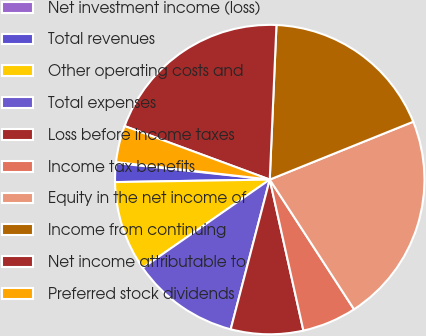<chart> <loc_0><loc_0><loc_500><loc_500><pie_chart><fcel>Net investment income (loss)<fcel>Total revenues<fcel>Other operating costs and<fcel>Total expenses<fcel>Loss before income taxes<fcel>Income tax benefits<fcel>Equity in the net income of<fcel>Income from continuing<fcel>Net income attributable to<fcel>Preferred stock dividends<nl><fcel>0.1%<fcel>1.96%<fcel>9.41%<fcel>11.27%<fcel>7.55%<fcel>5.68%<fcel>21.93%<fcel>18.21%<fcel>20.07%<fcel>3.82%<nl></chart> 